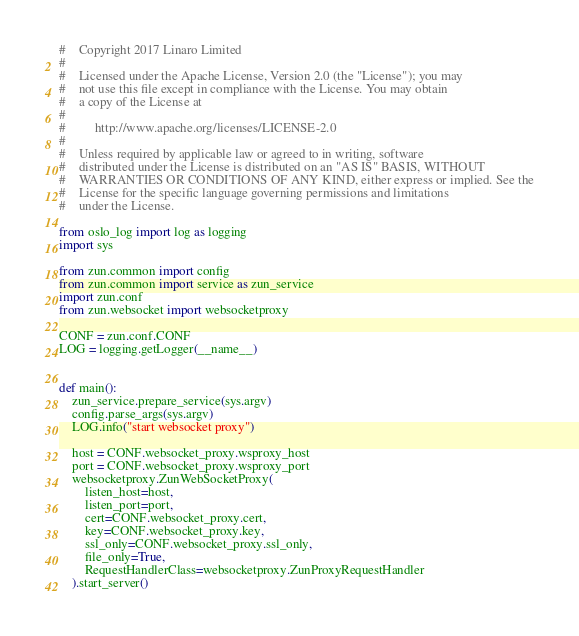Convert code to text. <code><loc_0><loc_0><loc_500><loc_500><_Python_>#    Copyright 2017 Linaro Limited
#
#    Licensed under the Apache License, Version 2.0 (the "License"); you may
#    not use this file except in compliance with the License. You may obtain
#    a copy of the License at
#
#         http://www.apache.org/licenses/LICENSE-2.0
#
#    Unless required by applicable law or agreed to in writing, software
#    distributed under the License is distributed on an "AS IS" BASIS, WITHOUT
#    WARRANTIES OR CONDITIONS OF ANY KIND, either express or implied. See the
#    License for the specific language governing permissions and limitations
#    under the License.

from oslo_log import log as logging
import sys

from zun.common import config
from zun.common import service as zun_service
import zun.conf
from zun.websocket import websocketproxy

CONF = zun.conf.CONF
LOG = logging.getLogger(__name__)


def main():
    zun_service.prepare_service(sys.argv)
    config.parse_args(sys.argv)
    LOG.info("start websocket proxy")

    host = CONF.websocket_proxy.wsproxy_host
    port = CONF.websocket_proxy.wsproxy_port
    websocketproxy.ZunWebSocketProxy(
        listen_host=host,
        listen_port=port,
        cert=CONF.websocket_proxy.cert,
        key=CONF.websocket_proxy.key,
        ssl_only=CONF.websocket_proxy.ssl_only,
        file_only=True,
        RequestHandlerClass=websocketproxy.ZunProxyRequestHandler
    ).start_server()
</code> 